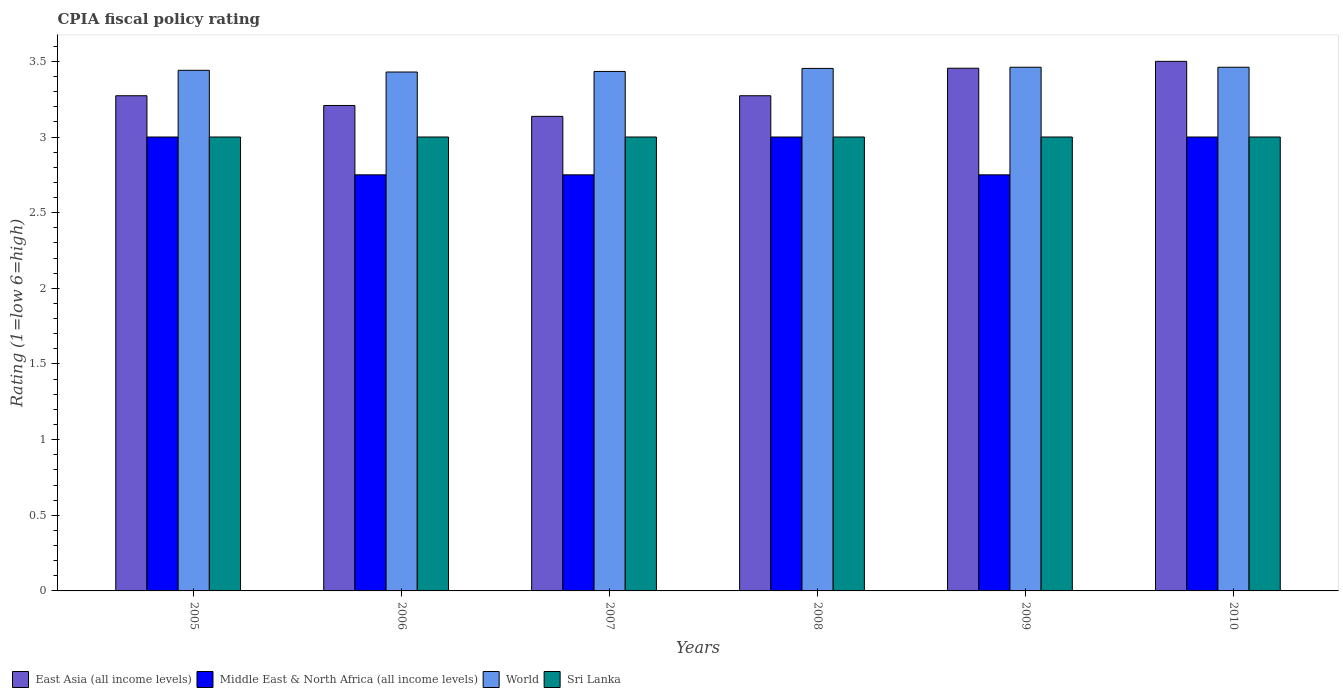How many different coloured bars are there?
Make the answer very short. 4. Are the number of bars per tick equal to the number of legend labels?
Make the answer very short. Yes. Are the number of bars on each tick of the X-axis equal?
Give a very brief answer. Yes. How many bars are there on the 2nd tick from the left?
Your response must be concise. 4. How many bars are there on the 1st tick from the right?
Provide a succinct answer. 4. In how many cases, is the number of bars for a given year not equal to the number of legend labels?
Give a very brief answer. 0. What is the CPIA rating in East Asia (all income levels) in 2008?
Offer a very short reply. 3.27. Across all years, what is the maximum CPIA rating in East Asia (all income levels)?
Your response must be concise. 3.5. Across all years, what is the minimum CPIA rating in Sri Lanka?
Your response must be concise. 3. In which year was the CPIA rating in Sri Lanka maximum?
Provide a succinct answer. 2005. In which year was the CPIA rating in Sri Lanka minimum?
Provide a short and direct response. 2005. What is the total CPIA rating in Middle East & North Africa (all income levels) in the graph?
Give a very brief answer. 17.25. What is the difference between the CPIA rating in World in 2005 and that in 2008?
Provide a short and direct response. -0.01. What is the average CPIA rating in East Asia (all income levels) per year?
Provide a succinct answer. 3.31. In the year 2006, what is the difference between the CPIA rating in Sri Lanka and CPIA rating in World?
Ensure brevity in your answer.  -0.43. What is the ratio of the CPIA rating in East Asia (all income levels) in 2009 to that in 2010?
Your response must be concise. 0.99. Is the CPIA rating in East Asia (all income levels) in 2005 less than that in 2007?
Ensure brevity in your answer.  No. Is the difference between the CPIA rating in Sri Lanka in 2005 and 2009 greater than the difference between the CPIA rating in World in 2005 and 2009?
Provide a short and direct response. Yes. What is the difference between the highest and the second highest CPIA rating in East Asia (all income levels)?
Provide a succinct answer. 0.05. What is the difference between the highest and the lowest CPIA rating in World?
Your response must be concise. 0.03. Is it the case that in every year, the sum of the CPIA rating in Sri Lanka and CPIA rating in East Asia (all income levels) is greater than the sum of CPIA rating in Middle East & North Africa (all income levels) and CPIA rating in World?
Offer a terse response. No. What does the 2nd bar from the left in 2010 represents?
Offer a very short reply. Middle East & North Africa (all income levels). What does the 3rd bar from the right in 2006 represents?
Your answer should be very brief. Middle East & North Africa (all income levels). How many years are there in the graph?
Ensure brevity in your answer.  6. What is the difference between two consecutive major ticks on the Y-axis?
Make the answer very short. 0.5. Are the values on the major ticks of Y-axis written in scientific E-notation?
Offer a very short reply. No. Where does the legend appear in the graph?
Provide a succinct answer. Bottom left. What is the title of the graph?
Your answer should be very brief. CPIA fiscal policy rating. Does "Cuba" appear as one of the legend labels in the graph?
Keep it short and to the point. No. What is the label or title of the X-axis?
Your response must be concise. Years. What is the label or title of the Y-axis?
Offer a terse response. Rating (1=low 6=high). What is the Rating (1=low 6=high) in East Asia (all income levels) in 2005?
Your response must be concise. 3.27. What is the Rating (1=low 6=high) of World in 2005?
Your response must be concise. 3.44. What is the Rating (1=low 6=high) of Sri Lanka in 2005?
Your answer should be compact. 3. What is the Rating (1=low 6=high) of East Asia (all income levels) in 2006?
Provide a succinct answer. 3.21. What is the Rating (1=low 6=high) in Middle East & North Africa (all income levels) in 2006?
Ensure brevity in your answer.  2.75. What is the Rating (1=low 6=high) in World in 2006?
Provide a short and direct response. 3.43. What is the Rating (1=low 6=high) of East Asia (all income levels) in 2007?
Offer a terse response. 3.14. What is the Rating (1=low 6=high) of Middle East & North Africa (all income levels) in 2007?
Provide a succinct answer. 2.75. What is the Rating (1=low 6=high) of World in 2007?
Give a very brief answer. 3.43. What is the Rating (1=low 6=high) in Sri Lanka in 2007?
Provide a succinct answer. 3. What is the Rating (1=low 6=high) in East Asia (all income levels) in 2008?
Provide a succinct answer. 3.27. What is the Rating (1=low 6=high) in Middle East & North Africa (all income levels) in 2008?
Your answer should be very brief. 3. What is the Rating (1=low 6=high) of World in 2008?
Provide a succinct answer. 3.45. What is the Rating (1=low 6=high) in East Asia (all income levels) in 2009?
Offer a terse response. 3.45. What is the Rating (1=low 6=high) in Middle East & North Africa (all income levels) in 2009?
Provide a succinct answer. 2.75. What is the Rating (1=low 6=high) in World in 2009?
Your answer should be very brief. 3.46. What is the Rating (1=low 6=high) of World in 2010?
Ensure brevity in your answer.  3.46. Across all years, what is the maximum Rating (1=low 6=high) of Middle East & North Africa (all income levels)?
Your answer should be very brief. 3. Across all years, what is the maximum Rating (1=low 6=high) of World?
Ensure brevity in your answer.  3.46. Across all years, what is the minimum Rating (1=low 6=high) in East Asia (all income levels)?
Offer a very short reply. 3.14. Across all years, what is the minimum Rating (1=low 6=high) of Middle East & North Africa (all income levels)?
Provide a succinct answer. 2.75. Across all years, what is the minimum Rating (1=low 6=high) of World?
Keep it short and to the point. 3.43. What is the total Rating (1=low 6=high) in East Asia (all income levels) in the graph?
Your answer should be very brief. 19.84. What is the total Rating (1=low 6=high) in Middle East & North Africa (all income levels) in the graph?
Offer a terse response. 17.25. What is the total Rating (1=low 6=high) of World in the graph?
Offer a terse response. 20.68. What is the total Rating (1=low 6=high) in Sri Lanka in the graph?
Offer a very short reply. 18. What is the difference between the Rating (1=low 6=high) in East Asia (all income levels) in 2005 and that in 2006?
Your response must be concise. 0.06. What is the difference between the Rating (1=low 6=high) of World in 2005 and that in 2006?
Your response must be concise. 0.01. What is the difference between the Rating (1=low 6=high) in Sri Lanka in 2005 and that in 2006?
Provide a succinct answer. 0. What is the difference between the Rating (1=low 6=high) in East Asia (all income levels) in 2005 and that in 2007?
Make the answer very short. 0.14. What is the difference between the Rating (1=low 6=high) in Middle East & North Africa (all income levels) in 2005 and that in 2007?
Keep it short and to the point. 0.25. What is the difference between the Rating (1=low 6=high) of World in 2005 and that in 2007?
Give a very brief answer. 0.01. What is the difference between the Rating (1=low 6=high) of Sri Lanka in 2005 and that in 2007?
Keep it short and to the point. 0. What is the difference between the Rating (1=low 6=high) in East Asia (all income levels) in 2005 and that in 2008?
Give a very brief answer. 0. What is the difference between the Rating (1=low 6=high) in Middle East & North Africa (all income levels) in 2005 and that in 2008?
Offer a terse response. 0. What is the difference between the Rating (1=low 6=high) in World in 2005 and that in 2008?
Offer a terse response. -0.01. What is the difference between the Rating (1=low 6=high) in East Asia (all income levels) in 2005 and that in 2009?
Your answer should be very brief. -0.18. What is the difference between the Rating (1=low 6=high) of Middle East & North Africa (all income levels) in 2005 and that in 2009?
Give a very brief answer. 0.25. What is the difference between the Rating (1=low 6=high) in World in 2005 and that in 2009?
Ensure brevity in your answer.  -0.02. What is the difference between the Rating (1=low 6=high) of Sri Lanka in 2005 and that in 2009?
Offer a very short reply. 0. What is the difference between the Rating (1=low 6=high) of East Asia (all income levels) in 2005 and that in 2010?
Make the answer very short. -0.23. What is the difference between the Rating (1=low 6=high) in World in 2005 and that in 2010?
Provide a short and direct response. -0.02. What is the difference between the Rating (1=low 6=high) of Sri Lanka in 2005 and that in 2010?
Offer a very short reply. 0. What is the difference between the Rating (1=low 6=high) in East Asia (all income levels) in 2006 and that in 2007?
Offer a very short reply. 0.07. What is the difference between the Rating (1=low 6=high) in Middle East & North Africa (all income levels) in 2006 and that in 2007?
Provide a short and direct response. 0. What is the difference between the Rating (1=low 6=high) of World in 2006 and that in 2007?
Offer a terse response. -0. What is the difference between the Rating (1=low 6=high) in Sri Lanka in 2006 and that in 2007?
Provide a succinct answer. 0. What is the difference between the Rating (1=low 6=high) of East Asia (all income levels) in 2006 and that in 2008?
Provide a short and direct response. -0.06. What is the difference between the Rating (1=low 6=high) of World in 2006 and that in 2008?
Offer a terse response. -0.02. What is the difference between the Rating (1=low 6=high) in East Asia (all income levels) in 2006 and that in 2009?
Provide a succinct answer. -0.25. What is the difference between the Rating (1=low 6=high) in World in 2006 and that in 2009?
Offer a very short reply. -0.03. What is the difference between the Rating (1=low 6=high) of East Asia (all income levels) in 2006 and that in 2010?
Your response must be concise. -0.29. What is the difference between the Rating (1=low 6=high) in World in 2006 and that in 2010?
Your response must be concise. -0.03. What is the difference between the Rating (1=low 6=high) of Sri Lanka in 2006 and that in 2010?
Offer a terse response. 0. What is the difference between the Rating (1=low 6=high) in East Asia (all income levels) in 2007 and that in 2008?
Offer a terse response. -0.14. What is the difference between the Rating (1=low 6=high) in World in 2007 and that in 2008?
Your answer should be very brief. -0.02. What is the difference between the Rating (1=low 6=high) in Sri Lanka in 2007 and that in 2008?
Provide a succinct answer. 0. What is the difference between the Rating (1=low 6=high) of East Asia (all income levels) in 2007 and that in 2009?
Offer a terse response. -0.32. What is the difference between the Rating (1=low 6=high) in Middle East & North Africa (all income levels) in 2007 and that in 2009?
Offer a very short reply. 0. What is the difference between the Rating (1=low 6=high) in World in 2007 and that in 2009?
Give a very brief answer. -0.03. What is the difference between the Rating (1=low 6=high) in Sri Lanka in 2007 and that in 2009?
Provide a succinct answer. 0. What is the difference between the Rating (1=low 6=high) of East Asia (all income levels) in 2007 and that in 2010?
Your answer should be very brief. -0.36. What is the difference between the Rating (1=low 6=high) of World in 2007 and that in 2010?
Keep it short and to the point. -0.03. What is the difference between the Rating (1=low 6=high) of East Asia (all income levels) in 2008 and that in 2009?
Provide a succinct answer. -0.18. What is the difference between the Rating (1=low 6=high) in Middle East & North Africa (all income levels) in 2008 and that in 2009?
Make the answer very short. 0.25. What is the difference between the Rating (1=low 6=high) in World in 2008 and that in 2009?
Provide a short and direct response. -0.01. What is the difference between the Rating (1=low 6=high) in East Asia (all income levels) in 2008 and that in 2010?
Keep it short and to the point. -0.23. What is the difference between the Rating (1=low 6=high) of World in 2008 and that in 2010?
Your answer should be very brief. -0.01. What is the difference between the Rating (1=low 6=high) in East Asia (all income levels) in 2009 and that in 2010?
Your answer should be compact. -0.05. What is the difference between the Rating (1=low 6=high) in Middle East & North Africa (all income levels) in 2009 and that in 2010?
Offer a terse response. -0.25. What is the difference between the Rating (1=low 6=high) of Sri Lanka in 2009 and that in 2010?
Make the answer very short. 0. What is the difference between the Rating (1=low 6=high) of East Asia (all income levels) in 2005 and the Rating (1=low 6=high) of Middle East & North Africa (all income levels) in 2006?
Provide a short and direct response. 0.52. What is the difference between the Rating (1=low 6=high) of East Asia (all income levels) in 2005 and the Rating (1=low 6=high) of World in 2006?
Provide a succinct answer. -0.16. What is the difference between the Rating (1=low 6=high) in East Asia (all income levels) in 2005 and the Rating (1=low 6=high) in Sri Lanka in 2006?
Make the answer very short. 0.27. What is the difference between the Rating (1=low 6=high) of Middle East & North Africa (all income levels) in 2005 and the Rating (1=low 6=high) of World in 2006?
Give a very brief answer. -0.43. What is the difference between the Rating (1=low 6=high) of World in 2005 and the Rating (1=low 6=high) of Sri Lanka in 2006?
Provide a succinct answer. 0.44. What is the difference between the Rating (1=low 6=high) in East Asia (all income levels) in 2005 and the Rating (1=low 6=high) in Middle East & North Africa (all income levels) in 2007?
Provide a succinct answer. 0.52. What is the difference between the Rating (1=low 6=high) of East Asia (all income levels) in 2005 and the Rating (1=low 6=high) of World in 2007?
Offer a very short reply. -0.16. What is the difference between the Rating (1=low 6=high) of East Asia (all income levels) in 2005 and the Rating (1=low 6=high) of Sri Lanka in 2007?
Ensure brevity in your answer.  0.27. What is the difference between the Rating (1=low 6=high) in Middle East & North Africa (all income levels) in 2005 and the Rating (1=low 6=high) in World in 2007?
Ensure brevity in your answer.  -0.43. What is the difference between the Rating (1=low 6=high) of World in 2005 and the Rating (1=low 6=high) of Sri Lanka in 2007?
Keep it short and to the point. 0.44. What is the difference between the Rating (1=low 6=high) of East Asia (all income levels) in 2005 and the Rating (1=low 6=high) of Middle East & North Africa (all income levels) in 2008?
Offer a very short reply. 0.27. What is the difference between the Rating (1=low 6=high) in East Asia (all income levels) in 2005 and the Rating (1=low 6=high) in World in 2008?
Your answer should be compact. -0.18. What is the difference between the Rating (1=low 6=high) of East Asia (all income levels) in 2005 and the Rating (1=low 6=high) of Sri Lanka in 2008?
Offer a very short reply. 0.27. What is the difference between the Rating (1=low 6=high) of Middle East & North Africa (all income levels) in 2005 and the Rating (1=low 6=high) of World in 2008?
Your answer should be compact. -0.45. What is the difference between the Rating (1=low 6=high) of Middle East & North Africa (all income levels) in 2005 and the Rating (1=low 6=high) of Sri Lanka in 2008?
Your answer should be very brief. 0. What is the difference between the Rating (1=low 6=high) in World in 2005 and the Rating (1=low 6=high) in Sri Lanka in 2008?
Provide a succinct answer. 0.44. What is the difference between the Rating (1=low 6=high) of East Asia (all income levels) in 2005 and the Rating (1=low 6=high) of Middle East & North Africa (all income levels) in 2009?
Keep it short and to the point. 0.52. What is the difference between the Rating (1=low 6=high) of East Asia (all income levels) in 2005 and the Rating (1=low 6=high) of World in 2009?
Offer a very short reply. -0.19. What is the difference between the Rating (1=low 6=high) in East Asia (all income levels) in 2005 and the Rating (1=low 6=high) in Sri Lanka in 2009?
Offer a very short reply. 0.27. What is the difference between the Rating (1=low 6=high) in Middle East & North Africa (all income levels) in 2005 and the Rating (1=low 6=high) in World in 2009?
Offer a terse response. -0.46. What is the difference between the Rating (1=low 6=high) in Middle East & North Africa (all income levels) in 2005 and the Rating (1=low 6=high) in Sri Lanka in 2009?
Your response must be concise. 0. What is the difference between the Rating (1=low 6=high) of World in 2005 and the Rating (1=low 6=high) of Sri Lanka in 2009?
Offer a very short reply. 0.44. What is the difference between the Rating (1=low 6=high) in East Asia (all income levels) in 2005 and the Rating (1=low 6=high) in Middle East & North Africa (all income levels) in 2010?
Provide a succinct answer. 0.27. What is the difference between the Rating (1=low 6=high) in East Asia (all income levels) in 2005 and the Rating (1=low 6=high) in World in 2010?
Provide a short and direct response. -0.19. What is the difference between the Rating (1=low 6=high) of East Asia (all income levels) in 2005 and the Rating (1=low 6=high) of Sri Lanka in 2010?
Provide a short and direct response. 0.27. What is the difference between the Rating (1=low 6=high) in Middle East & North Africa (all income levels) in 2005 and the Rating (1=low 6=high) in World in 2010?
Ensure brevity in your answer.  -0.46. What is the difference between the Rating (1=low 6=high) of World in 2005 and the Rating (1=low 6=high) of Sri Lanka in 2010?
Your answer should be very brief. 0.44. What is the difference between the Rating (1=low 6=high) in East Asia (all income levels) in 2006 and the Rating (1=low 6=high) in Middle East & North Africa (all income levels) in 2007?
Provide a short and direct response. 0.46. What is the difference between the Rating (1=low 6=high) of East Asia (all income levels) in 2006 and the Rating (1=low 6=high) of World in 2007?
Your answer should be very brief. -0.23. What is the difference between the Rating (1=low 6=high) of East Asia (all income levels) in 2006 and the Rating (1=low 6=high) of Sri Lanka in 2007?
Offer a very short reply. 0.21. What is the difference between the Rating (1=low 6=high) in Middle East & North Africa (all income levels) in 2006 and the Rating (1=low 6=high) in World in 2007?
Give a very brief answer. -0.68. What is the difference between the Rating (1=low 6=high) of Middle East & North Africa (all income levels) in 2006 and the Rating (1=low 6=high) of Sri Lanka in 2007?
Keep it short and to the point. -0.25. What is the difference between the Rating (1=low 6=high) in World in 2006 and the Rating (1=low 6=high) in Sri Lanka in 2007?
Keep it short and to the point. 0.43. What is the difference between the Rating (1=low 6=high) of East Asia (all income levels) in 2006 and the Rating (1=low 6=high) of Middle East & North Africa (all income levels) in 2008?
Provide a short and direct response. 0.21. What is the difference between the Rating (1=low 6=high) of East Asia (all income levels) in 2006 and the Rating (1=low 6=high) of World in 2008?
Provide a succinct answer. -0.24. What is the difference between the Rating (1=low 6=high) in East Asia (all income levels) in 2006 and the Rating (1=low 6=high) in Sri Lanka in 2008?
Offer a terse response. 0.21. What is the difference between the Rating (1=low 6=high) of Middle East & North Africa (all income levels) in 2006 and the Rating (1=low 6=high) of World in 2008?
Ensure brevity in your answer.  -0.7. What is the difference between the Rating (1=low 6=high) of Middle East & North Africa (all income levels) in 2006 and the Rating (1=low 6=high) of Sri Lanka in 2008?
Provide a short and direct response. -0.25. What is the difference between the Rating (1=low 6=high) in World in 2006 and the Rating (1=low 6=high) in Sri Lanka in 2008?
Ensure brevity in your answer.  0.43. What is the difference between the Rating (1=low 6=high) in East Asia (all income levels) in 2006 and the Rating (1=low 6=high) in Middle East & North Africa (all income levels) in 2009?
Provide a succinct answer. 0.46. What is the difference between the Rating (1=low 6=high) in East Asia (all income levels) in 2006 and the Rating (1=low 6=high) in World in 2009?
Keep it short and to the point. -0.25. What is the difference between the Rating (1=low 6=high) of East Asia (all income levels) in 2006 and the Rating (1=low 6=high) of Sri Lanka in 2009?
Provide a succinct answer. 0.21. What is the difference between the Rating (1=low 6=high) of Middle East & North Africa (all income levels) in 2006 and the Rating (1=low 6=high) of World in 2009?
Provide a short and direct response. -0.71. What is the difference between the Rating (1=low 6=high) of World in 2006 and the Rating (1=low 6=high) of Sri Lanka in 2009?
Give a very brief answer. 0.43. What is the difference between the Rating (1=low 6=high) of East Asia (all income levels) in 2006 and the Rating (1=low 6=high) of Middle East & North Africa (all income levels) in 2010?
Ensure brevity in your answer.  0.21. What is the difference between the Rating (1=low 6=high) in East Asia (all income levels) in 2006 and the Rating (1=low 6=high) in World in 2010?
Make the answer very short. -0.25. What is the difference between the Rating (1=low 6=high) of East Asia (all income levels) in 2006 and the Rating (1=low 6=high) of Sri Lanka in 2010?
Make the answer very short. 0.21. What is the difference between the Rating (1=low 6=high) in Middle East & North Africa (all income levels) in 2006 and the Rating (1=low 6=high) in World in 2010?
Make the answer very short. -0.71. What is the difference between the Rating (1=low 6=high) in World in 2006 and the Rating (1=low 6=high) in Sri Lanka in 2010?
Offer a very short reply. 0.43. What is the difference between the Rating (1=low 6=high) of East Asia (all income levels) in 2007 and the Rating (1=low 6=high) of Middle East & North Africa (all income levels) in 2008?
Offer a very short reply. 0.14. What is the difference between the Rating (1=low 6=high) in East Asia (all income levels) in 2007 and the Rating (1=low 6=high) in World in 2008?
Make the answer very short. -0.32. What is the difference between the Rating (1=low 6=high) of East Asia (all income levels) in 2007 and the Rating (1=low 6=high) of Sri Lanka in 2008?
Offer a terse response. 0.14. What is the difference between the Rating (1=low 6=high) in Middle East & North Africa (all income levels) in 2007 and the Rating (1=low 6=high) in World in 2008?
Offer a very short reply. -0.7. What is the difference between the Rating (1=low 6=high) of World in 2007 and the Rating (1=low 6=high) of Sri Lanka in 2008?
Your answer should be compact. 0.43. What is the difference between the Rating (1=low 6=high) in East Asia (all income levels) in 2007 and the Rating (1=low 6=high) in Middle East & North Africa (all income levels) in 2009?
Provide a succinct answer. 0.39. What is the difference between the Rating (1=low 6=high) of East Asia (all income levels) in 2007 and the Rating (1=low 6=high) of World in 2009?
Make the answer very short. -0.32. What is the difference between the Rating (1=low 6=high) in East Asia (all income levels) in 2007 and the Rating (1=low 6=high) in Sri Lanka in 2009?
Offer a very short reply. 0.14. What is the difference between the Rating (1=low 6=high) in Middle East & North Africa (all income levels) in 2007 and the Rating (1=low 6=high) in World in 2009?
Your answer should be very brief. -0.71. What is the difference between the Rating (1=low 6=high) in World in 2007 and the Rating (1=low 6=high) in Sri Lanka in 2009?
Give a very brief answer. 0.43. What is the difference between the Rating (1=low 6=high) of East Asia (all income levels) in 2007 and the Rating (1=low 6=high) of Middle East & North Africa (all income levels) in 2010?
Your response must be concise. 0.14. What is the difference between the Rating (1=low 6=high) of East Asia (all income levels) in 2007 and the Rating (1=low 6=high) of World in 2010?
Ensure brevity in your answer.  -0.32. What is the difference between the Rating (1=low 6=high) of East Asia (all income levels) in 2007 and the Rating (1=low 6=high) of Sri Lanka in 2010?
Provide a short and direct response. 0.14. What is the difference between the Rating (1=low 6=high) of Middle East & North Africa (all income levels) in 2007 and the Rating (1=low 6=high) of World in 2010?
Your response must be concise. -0.71. What is the difference between the Rating (1=low 6=high) of World in 2007 and the Rating (1=low 6=high) of Sri Lanka in 2010?
Provide a short and direct response. 0.43. What is the difference between the Rating (1=low 6=high) of East Asia (all income levels) in 2008 and the Rating (1=low 6=high) of Middle East & North Africa (all income levels) in 2009?
Give a very brief answer. 0.52. What is the difference between the Rating (1=low 6=high) of East Asia (all income levels) in 2008 and the Rating (1=low 6=high) of World in 2009?
Your answer should be very brief. -0.19. What is the difference between the Rating (1=low 6=high) in East Asia (all income levels) in 2008 and the Rating (1=low 6=high) in Sri Lanka in 2009?
Provide a succinct answer. 0.27. What is the difference between the Rating (1=low 6=high) of Middle East & North Africa (all income levels) in 2008 and the Rating (1=low 6=high) of World in 2009?
Give a very brief answer. -0.46. What is the difference between the Rating (1=low 6=high) in Middle East & North Africa (all income levels) in 2008 and the Rating (1=low 6=high) in Sri Lanka in 2009?
Provide a short and direct response. 0. What is the difference between the Rating (1=low 6=high) of World in 2008 and the Rating (1=low 6=high) of Sri Lanka in 2009?
Provide a succinct answer. 0.45. What is the difference between the Rating (1=low 6=high) in East Asia (all income levels) in 2008 and the Rating (1=low 6=high) in Middle East & North Africa (all income levels) in 2010?
Your answer should be compact. 0.27. What is the difference between the Rating (1=low 6=high) in East Asia (all income levels) in 2008 and the Rating (1=low 6=high) in World in 2010?
Give a very brief answer. -0.19. What is the difference between the Rating (1=low 6=high) of East Asia (all income levels) in 2008 and the Rating (1=low 6=high) of Sri Lanka in 2010?
Make the answer very short. 0.27. What is the difference between the Rating (1=low 6=high) of Middle East & North Africa (all income levels) in 2008 and the Rating (1=low 6=high) of World in 2010?
Offer a terse response. -0.46. What is the difference between the Rating (1=low 6=high) in Middle East & North Africa (all income levels) in 2008 and the Rating (1=low 6=high) in Sri Lanka in 2010?
Provide a short and direct response. 0. What is the difference between the Rating (1=low 6=high) in World in 2008 and the Rating (1=low 6=high) in Sri Lanka in 2010?
Your answer should be very brief. 0.45. What is the difference between the Rating (1=low 6=high) in East Asia (all income levels) in 2009 and the Rating (1=low 6=high) in Middle East & North Africa (all income levels) in 2010?
Provide a short and direct response. 0.45. What is the difference between the Rating (1=low 6=high) in East Asia (all income levels) in 2009 and the Rating (1=low 6=high) in World in 2010?
Offer a terse response. -0.01. What is the difference between the Rating (1=low 6=high) of East Asia (all income levels) in 2009 and the Rating (1=low 6=high) of Sri Lanka in 2010?
Keep it short and to the point. 0.45. What is the difference between the Rating (1=low 6=high) of Middle East & North Africa (all income levels) in 2009 and the Rating (1=low 6=high) of World in 2010?
Give a very brief answer. -0.71. What is the difference between the Rating (1=low 6=high) in Middle East & North Africa (all income levels) in 2009 and the Rating (1=low 6=high) in Sri Lanka in 2010?
Your answer should be compact. -0.25. What is the difference between the Rating (1=low 6=high) of World in 2009 and the Rating (1=low 6=high) of Sri Lanka in 2010?
Give a very brief answer. 0.46. What is the average Rating (1=low 6=high) of East Asia (all income levels) per year?
Your answer should be very brief. 3.31. What is the average Rating (1=low 6=high) of Middle East & North Africa (all income levels) per year?
Your answer should be compact. 2.88. What is the average Rating (1=low 6=high) in World per year?
Provide a succinct answer. 3.45. In the year 2005, what is the difference between the Rating (1=low 6=high) of East Asia (all income levels) and Rating (1=low 6=high) of Middle East & North Africa (all income levels)?
Give a very brief answer. 0.27. In the year 2005, what is the difference between the Rating (1=low 6=high) in East Asia (all income levels) and Rating (1=low 6=high) in World?
Your response must be concise. -0.17. In the year 2005, what is the difference between the Rating (1=low 6=high) in East Asia (all income levels) and Rating (1=low 6=high) in Sri Lanka?
Keep it short and to the point. 0.27. In the year 2005, what is the difference between the Rating (1=low 6=high) in Middle East & North Africa (all income levels) and Rating (1=low 6=high) in World?
Provide a succinct answer. -0.44. In the year 2005, what is the difference between the Rating (1=low 6=high) of World and Rating (1=low 6=high) of Sri Lanka?
Provide a short and direct response. 0.44. In the year 2006, what is the difference between the Rating (1=low 6=high) in East Asia (all income levels) and Rating (1=low 6=high) in Middle East & North Africa (all income levels)?
Keep it short and to the point. 0.46. In the year 2006, what is the difference between the Rating (1=low 6=high) of East Asia (all income levels) and Rating (1=low 6=high) of World?
Your response must be concise. -0.22. In the year 2006, what is the difference between the Rating (1=low 6=high) of East Asia (all income levels) and Rating (1=low 6=high) of Sri Lanka?
Provide a succinct answer. 0.21. In the year 2006, what is the difference between the Rating (1=low 6=high) of Middle East & North Africa (all income levels) and Rating (1=low 6=high) of World?
Keep it short and to the point. -0.68. In the year 2006, what is the difference between the Rating (1=low 6=high) in World and Rating (1=low 6=high) in Sri Lanka?
Provide a short and direct response. 0.43. In the year 2007, what is the difference between the Rating (1=low 6=high) in East Asia (all income levels) and Rating (1=low 6=high) in Middle East & North Africa (all income levels)?
Your answer should be compact. 0.39. In the year 2007, what is the difference between the Rating (1=low 6=high) in East Asia (all income levels) and Rating (1=low 6=high) in World?
Give a very brief answer. -0.3. In the year 2007, what is the difference between the Rating (1=low 6=high) of East Asia (all income levels) and Rating (1=low 6=high) of Sri Lanka?
Your answer should be compact. 0.14. In the year 2007, what is the difference between the Rating (1=low 6=high) of Middle East & North Africa (all income levels) and Rating (1=low 6=high) of World?
Ensure brevity in your answer.  -0.68. In the year 2007, what is the difference between the Rating (1=low 6=high) of Middle East & North Africa (all income levels) and Rating (1=low 6=high) of Sri Lanka?
Make the answer very short. -0.25. In the year 2007, what is the difference between the Rating (1=low 6=high) in World and Rating (1=low 6=high) in Sri Lanka?
Your answer should be very brief. 0.43. In the year 2008, what is the difference between the Rating (1=low 6=high) of East Asia (all income levels) and Rating (1=low 6=high) of Middle East & North Africa (all income levels)?
Provide a succinct answer. 0.27. In the year 2008, what is the difference between the Rating (1=low 6=high) in East Asia (all income levels) and Rating (1=low 6=high) in World?
Your response must be concise. -0.18. In the year 2008, what is the difference between the Rating (1=low 6=high) of East Asia (all income levels) and Rating (1=low 6=high) of Sri Lanka?
Your response must be concise. 0.27. In the year 2008, what is the difference between the Rating (1=low 6=high) of Middle East & North Africa (all income levels) and Rating (1=low 6=high) of World?
Keep it short and to the point. -0.45. In the year 2008, what is the difference between the Rating (1=low 6=high) in World and Rating (1=low 6=high) in Sri Lanka?
Offer a very short reply. 0.45. In the year 2009, what is the difference between the Rating (1=low 6=high) in East Asia (all income levels) and Rating (1=low 6=high) in Middle East & North Africa (all income levels)?
Provide a succinct answer. 0.7. In the year 2009, what is the difference between the Rating (1=low 6=high) in East Asia (all income levels) and Rating (1=low 6=high) in World?
Offer a very short reply. -0.01. In the year 2009, what is the difference between the Rating (1=low 6=high) of East Asia (all income levels) and Rating (1=low 6=high) of Sri Lanka?
Your response must be concise. 0.45. In the year 2009, what is the difference between the Rating (1=low 6=high) of Middle East & North Africa (all income levels) and Rating (1=low 6=high) of World?
Keep it short and to the point. -0.71. In the year 2009, what is the difference between the Rating (1=low 6=high) of Middle East & North Africa (all income levels) and Rating (1=low 6=high) of Sri Lanka?
Make the answer very short. -0.25. In the year 2009, what is the difference between the Rating (1=low 6=high) in World and Rating (1=low 6=high) in Sri Lanka?
Make the answer very short. 0.46. In the year 2010, what is the difference between the Rating (1=low 6=high) of East Asia (all income levels) and Rating (1=low 6=high) of World?
Make the answer very short. 0.04. In the year 2010, what is the difference between the Rating (1=low 6=high) in Middle East & North Africa (all income levels) and Rating (1=low 6=high) in World?
Offer a terse response. -0.46. In the year 2010, what is the difference between the Rating (1=low 6=high) in World and Rating (1=low 6=high) in Sri Lanka?
Keep it short and to the point. 0.46. What is the ratio of the Rating (1=low 6=high) in East Asia (all income levels) in 2005 to that in 2006?
Give a very brief answer. 1.02. What is the ratio of the Rating (1=low 6=high) of Sri Lanka in 2005 to that in 2006?
Your response must be concise. 1. What is the ratio of the Rating (1=low 6=high) of East Asia (all income levels) in 2005 to that in 2007?
Give a very brief answer. 1.04. What is the ratio of the Rating (1=low 6=high) of World in 2005 to that in 2007?
Keep it short and to the point. 1. What is the ratio of the Rating (1=low 6=high) in East Asia (all income levels) in 2005 to that in 2008?
Keep it short and to the point. 1. What is the ratio of the Rating (1=low 6=high) in Middle East & North Africa (all income levels) in 2005 to that in 2008?
Ensure brevity in your answer.  1. What is the ratio of the Rating (1=low 6=high) of World in 2005 to that in 2008?
Give a very brief answer. 1. What is the ratio of the Rating (1=low 6=high) in Sri Lanka in 2005 to that in 2008?
Give a very brief answer. 1. What is the ratio of the Rating (1=low 6=high) of Middle East & North Africa (all income levels) in 2005 to that in 2009?
Keep it short and to the point. 1.09. What is the ratio of the Rating (1=low 6=high) in World in 2005 to that in 2009?
Your answer should be very brief. 0.99. What is the ratio of the Rating (1=low 6=high) in East Asia (all income levels) in 2005 to that in 2010?
Provide a short and direct response. 0.94. What is the ratio of the Rating (1=low 6=high) of Middle East & North Africa (all income levels) in 2005 to that in 2010?
Ensure brevity in your answer.  1. What is the ratio of the Rating (1=low 6=high) of Sri Lanka in 2005 to that in 2010?
Your answer should be compact. 1. What is the ratio of the Rating (1=low 6=high) in East Asia (all income levels) in 2006 to that in 2007?
Offer a terse response. 1.02. What is the ratio of the Rating (1=low 6=high) of World in 2006 to that in 2007?
Your response must be concise. 1. What is the ratio of the Rating (1=low 6=high) in Sri Lanka in 2006 to that in 2007?
Provide a short and direct response. 1. What is the ratio of the Rating (1=low 6=high) in East Asia (all income levels) in 2006 to that in 2008?
Your answer should be very brief. 0.98. What is the ratio of the Rating (1=low 6=high) of Sri Lanka in 2006 to that in 2008?
Provide a succinct answer. 1. What is the ratio of the Rating (1=low 6=high) in East Asia (all income levels) in 2006 to that in 2009?
Offer a terse response. 0.93. What is the ratio of the Rating (1=low 6=high) in World in 2006 to that in 2009?
Your answer should be very brief. 0.99. What is the ratio of the Rating (1=low 6=high) in Middle East & North Africa (all income levels) in 2006 to that in 2010?
Offer a terse response. 0.92. What is the ratio of the Rating (1=low 6=high) of World in 2006 to that in 2010?
Provide a short and direct response. 0.99. What is the ratio of the Rating (1=low 6=high) of East Asia (all income levels) in 2007 to that in 2008?
Your response must be concise. 0.96. What is the ratio of the Rating (1=low 6=high) of Middle East & North Africa (all income levels) in 2007 to that in 2008?
Your response must be concise. 0.92. What is the ratio of the Rating (1=low 6=high) in World in 2007 to that in 2008?
Keep it short and to the point. 0.99. What is the ratio of the Rating (1=low 6=high) of East Asia (all income levels) in 2007 to that in 2009?
Make the answer very short. 0.91. What is the ratio of the Rating (1=low 6=high) in Middle East & North Africa (all income levels) in 2007 to that in 2009?
Provide a succinct answer. 1. What is the ratio of the Rating (1=low 6=high) of Sri Lanka in 2007 to that in 2009?
Make the answer very short. 1. What is the ratio of the Rating (1=low 6=high) in East Asia (all income levels) in 2007 to that in 2010?
Your answer should be very brief. 0.9. What is the ratio of the Rating (1=low 6=high) of World in 2007 to that in 2010?
Give a very brief answer. 0.99. What is the ratio of the Rating (1=low 6=high) of Middle East & North Africa (all income levels) in 2008 to that in 2009?
Make the answer very short. 1.09. What is the ratio of the Rating (1=low 6=high) in Sri Lanka in 2008 to that in 2009?
Make the answer very short. 1. What is the ratio of the Rating (1=low 6=high) of East Asia (all income levels) in 2008 to that in 2010?
Keep it short and to the point. 0.94. What is the ratio of the Rating (1=low 6=high) of World in 2008 to that in 2010?
Offer a very short reply. 1. What is the ratio of the Rating (1=low 6=high) in Sri Lanka in 2008 to that in 2010?
Your answer should be very brief. 1. What is the ratio of the Rating (1=low 6=high) of Middle East & North Africa (all income levels) in 2009 to that in 2010?
Keep it short and to the point. 0.92. What is the difference between the highest and the second highest Rating (1=low 6=high) of East Asia (all income levels)?
Keep it short and to the point. 0.05. What is the difference between the highest and the second highest Rating (1=low 6=high) in Sri Lanka?
Keep it short and to the point. 0. What is the difference between the highest and the lowest Rating (1=low 6=high) in East Asia (all income levels)?
Your answer should be compact. 0.36. What is the difference between the highest and the lowest Rating (1=low 6=high) of Middle East & North Africa (all income levels)?
Give a very brief answer. 0.25. What is the difference between the highest and the lowest Rating (1=low 6=high) in World?
Your answer should be compact. 0.03. 